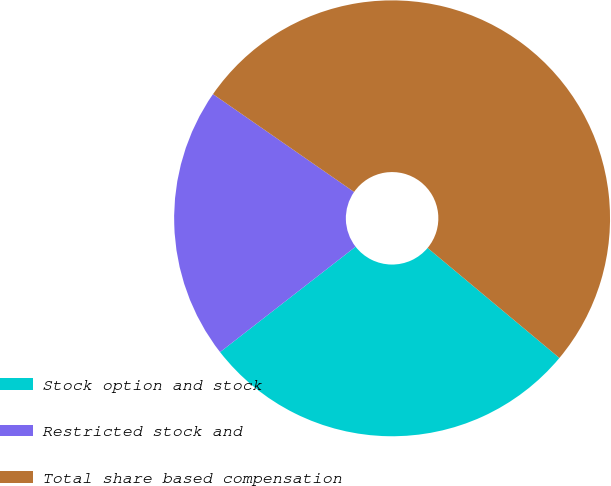Convert chart. <chart><loc_0><loc_0><loc_500><loc_500><pie_chart><fcel>Stock option and stock<fcel>Restricted stock and<fcel>Total share based compensation<nl><fcel>28.41%<fcel>20.17%<fcel>51.42%<nl></chart> 